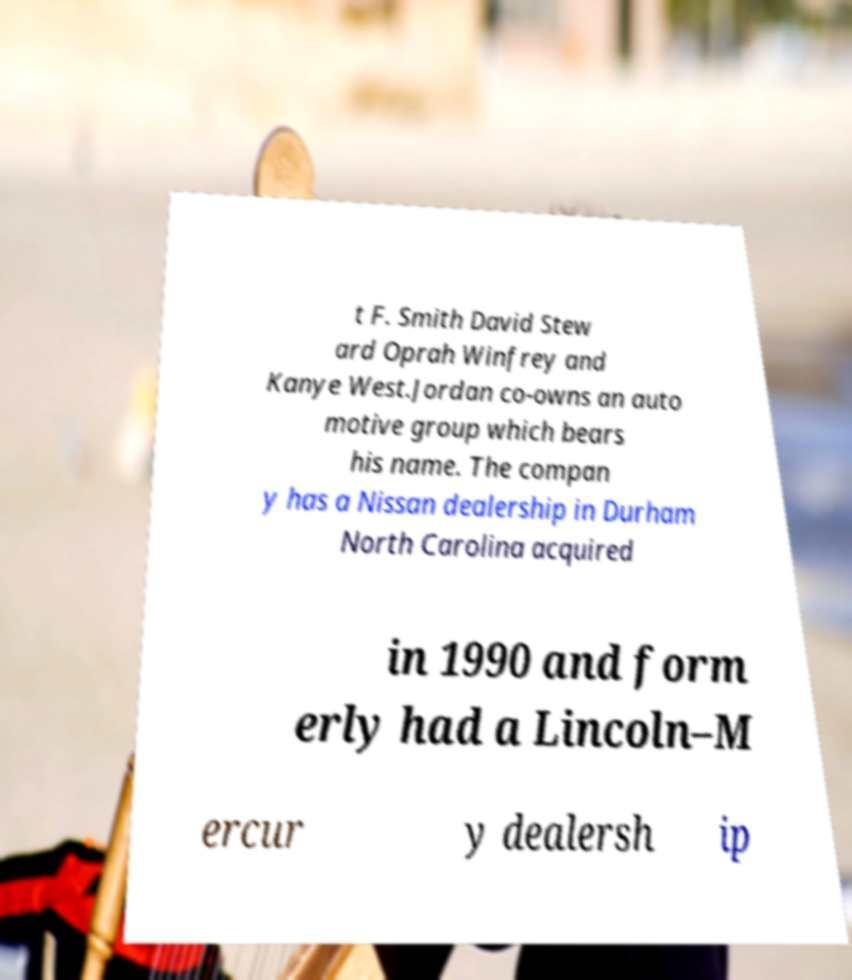Please read and relay the text visible in this image. What does it say? t F. Smith David Stew ard Oprah Winfrey and Kanye West.Jordan co-owns an auto motive group which bears his name. The compan y has a Nissan dealership in Durham North Carolina acquired in 1990 and form erly had a Lincoln–M ercur y dealersh ip 